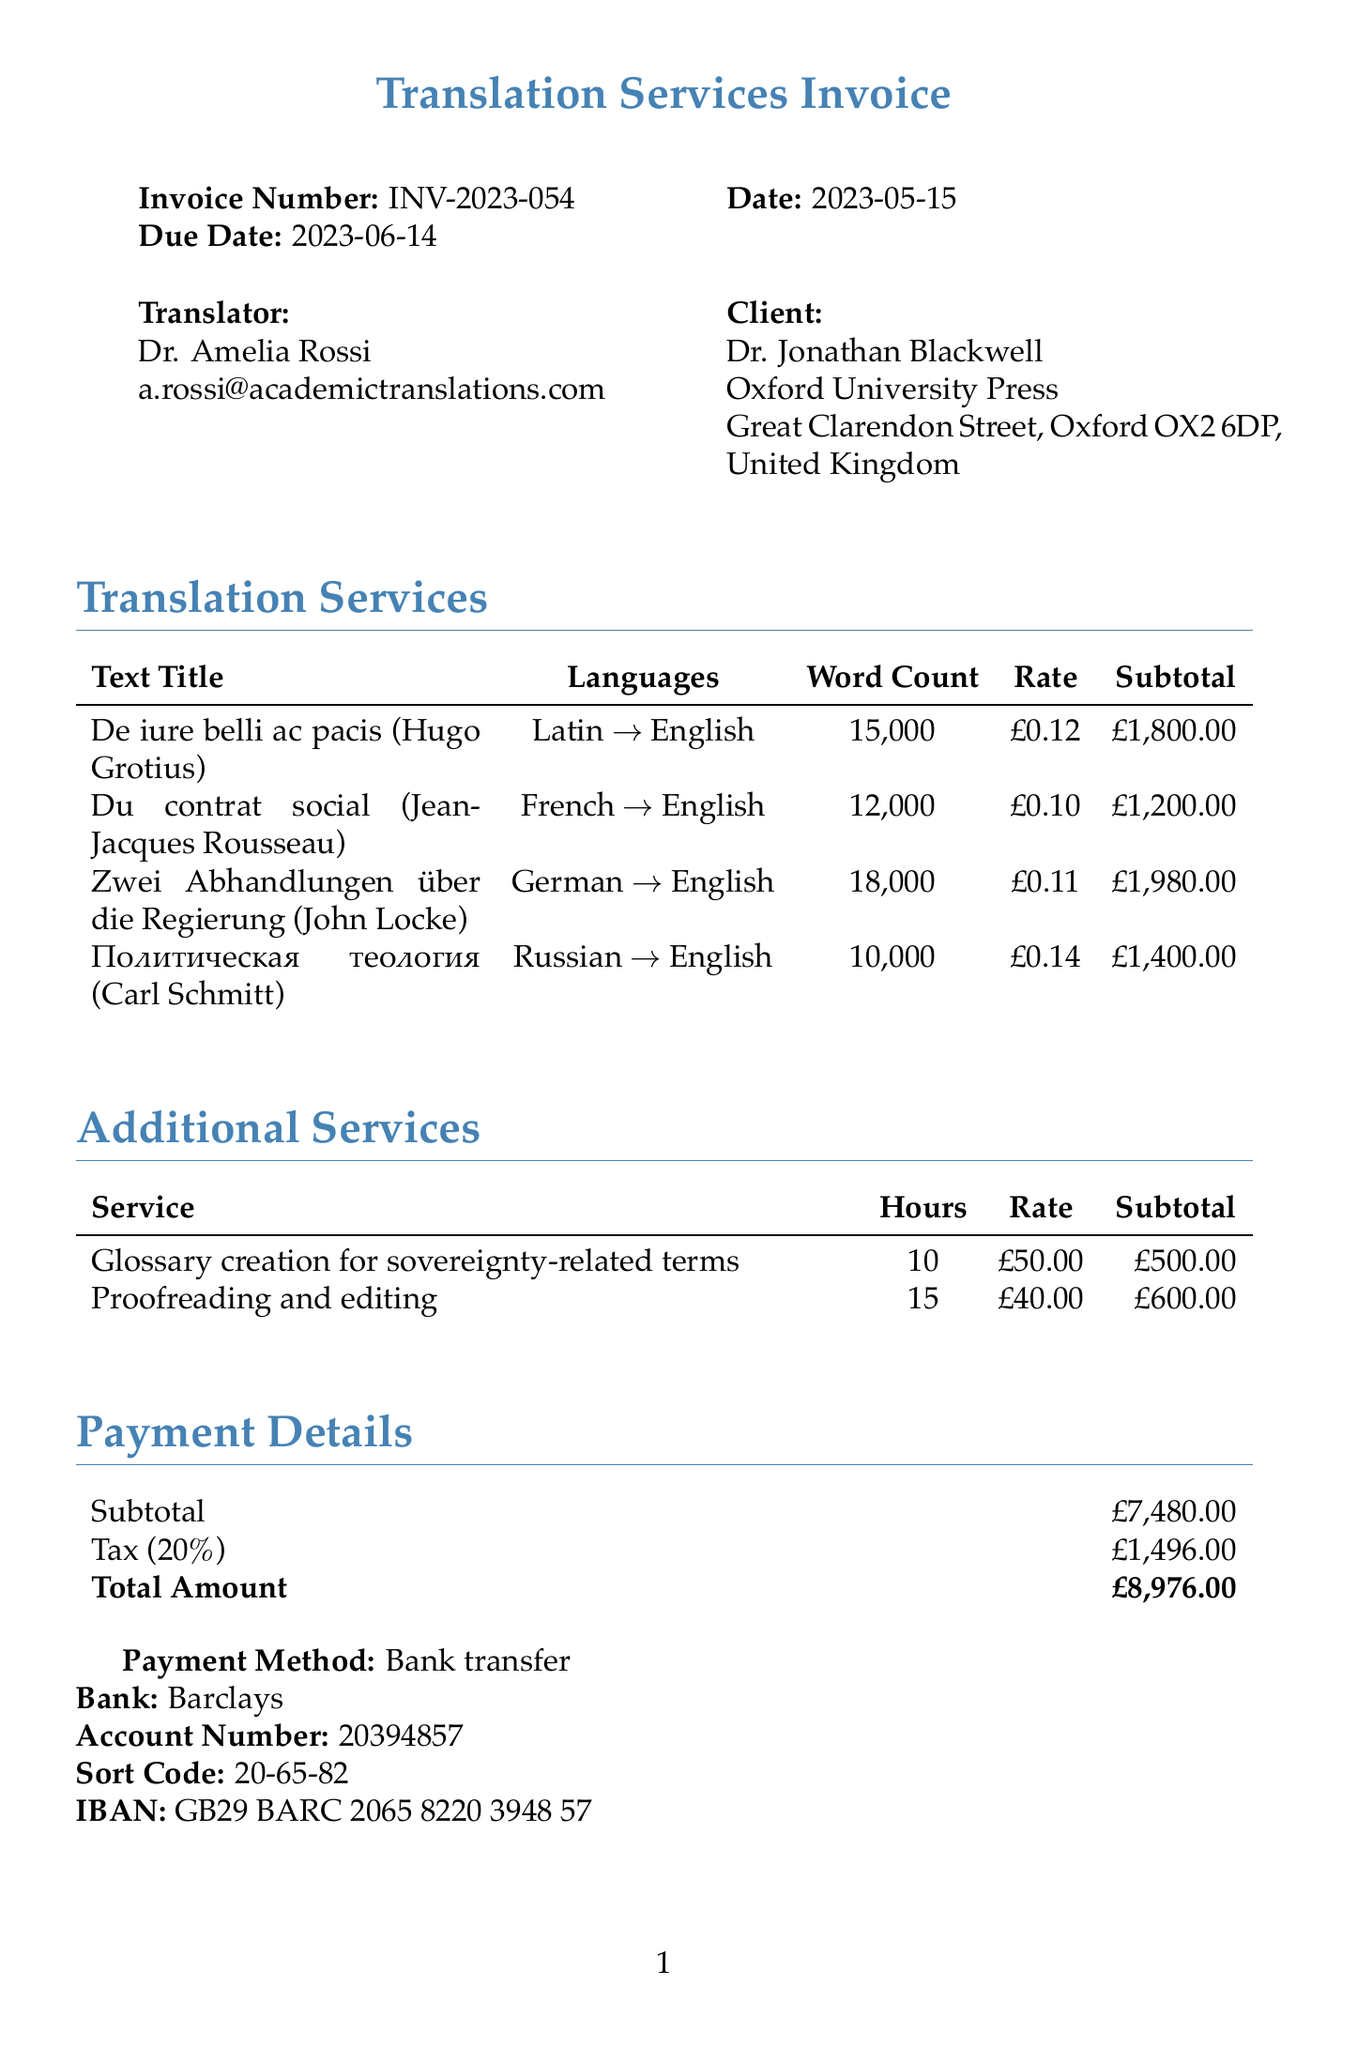What is the invoice number? The invoice number is listed at the top of the document.
Answer: INV-2023-054 Who is the translator? The translator's name is mentioned in the client section of the document.
Answer: Dr. Amelia Rossi What is the due date for the invoice? The due date is specified under the invoice details.
Answer: 2023-06-14 How many words are in "De iure belli ac pacis"? The word count for this text is provided in the translation services section.
Answer: 15000 What is the subtotal for translations? The subtotal for translations is calculated from the listed translation services.
Answer: £7480.00 What additional service was provided for 10 hours? This service is mentioned in the additional services section of the document.
Answer: Glossary creation for sovereignty-related terms What is the tax rate applied to the subtotal? The tax rate is explicitly stated in the payment details section.
Answer: 20% What payment method is specified in the document? The payment method is detailed in the payment information section.
Answer: Bank transfer What is the total amount due? The total amount is clearly indicated at the end of the payment details section.
Answer: £8976.00 